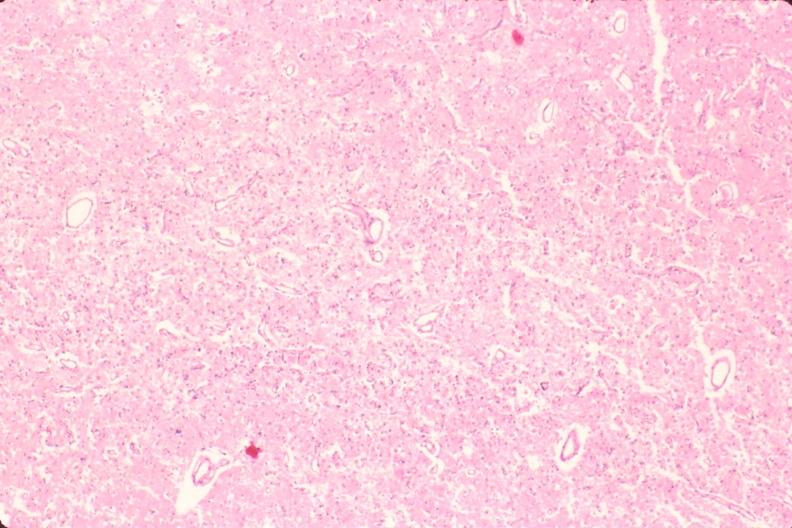what does this image show?
Answer the question using a single word or phrase. Brain 